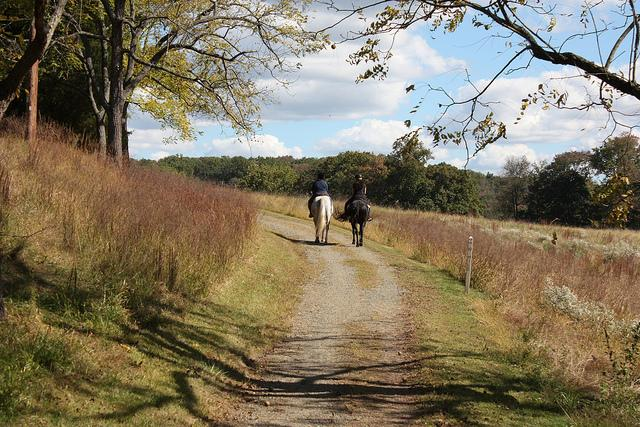What animals are present?

Choices:
A) horse
B) dog
C) deer
D) giraffe horse 